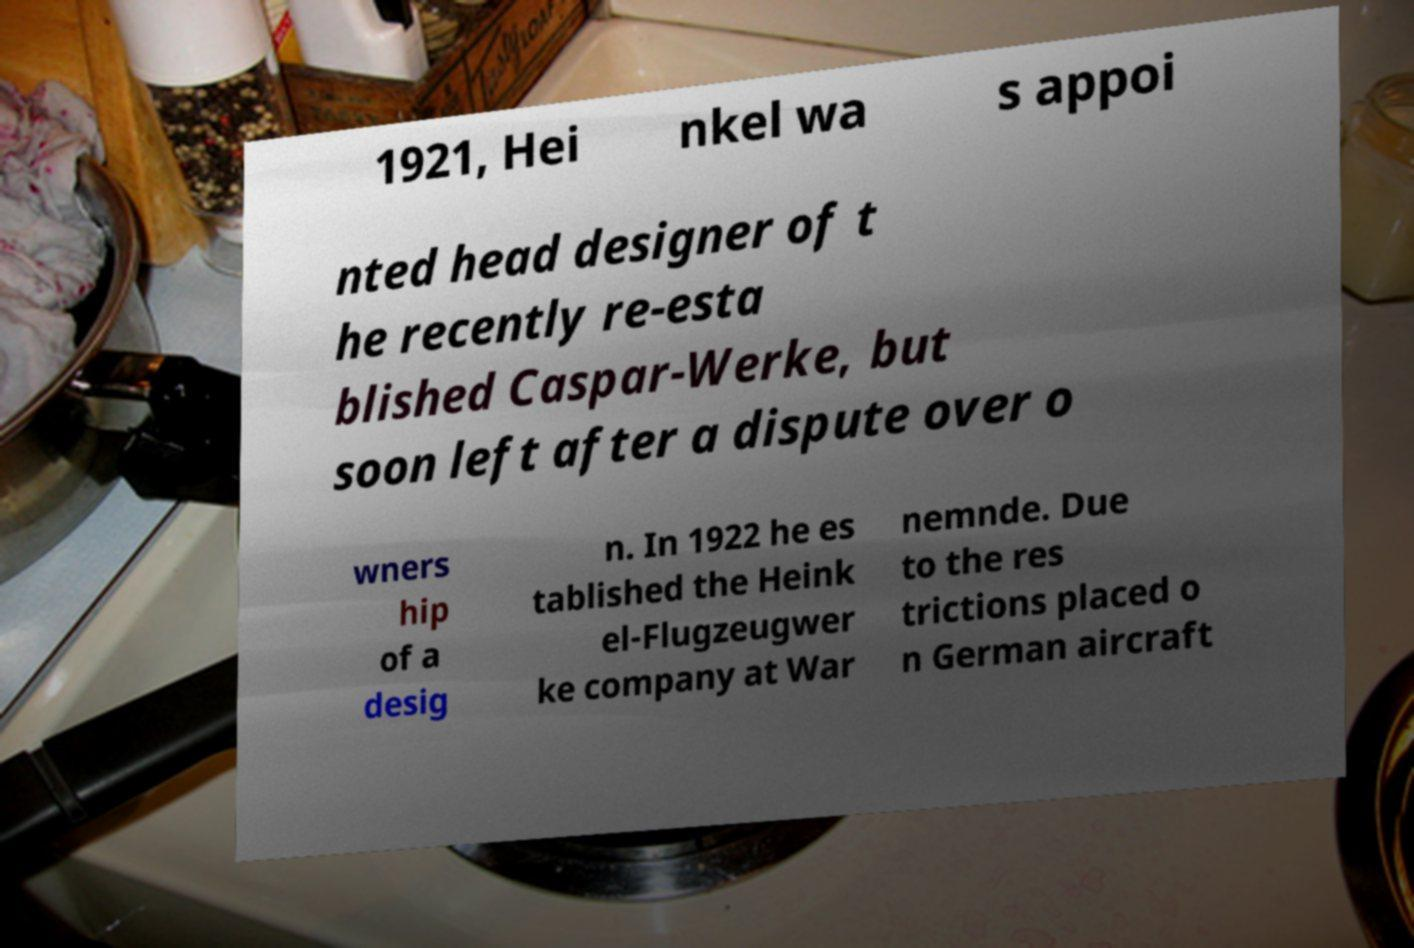Can you read and provide the text displayed in the image?This photo seems to have some interesting text. Can you extract and type it out for me? 1921, Hei nkel wa s appoi nted head designer of t he recently re-esta blished Caspar-Werke, but soon left after a dispute over o wners hip of a desig n. In 1922 he es tablished the Heink el-Flugzeugwer ke company at War nemnde. Due to the res trictions placed o n German aircraft 